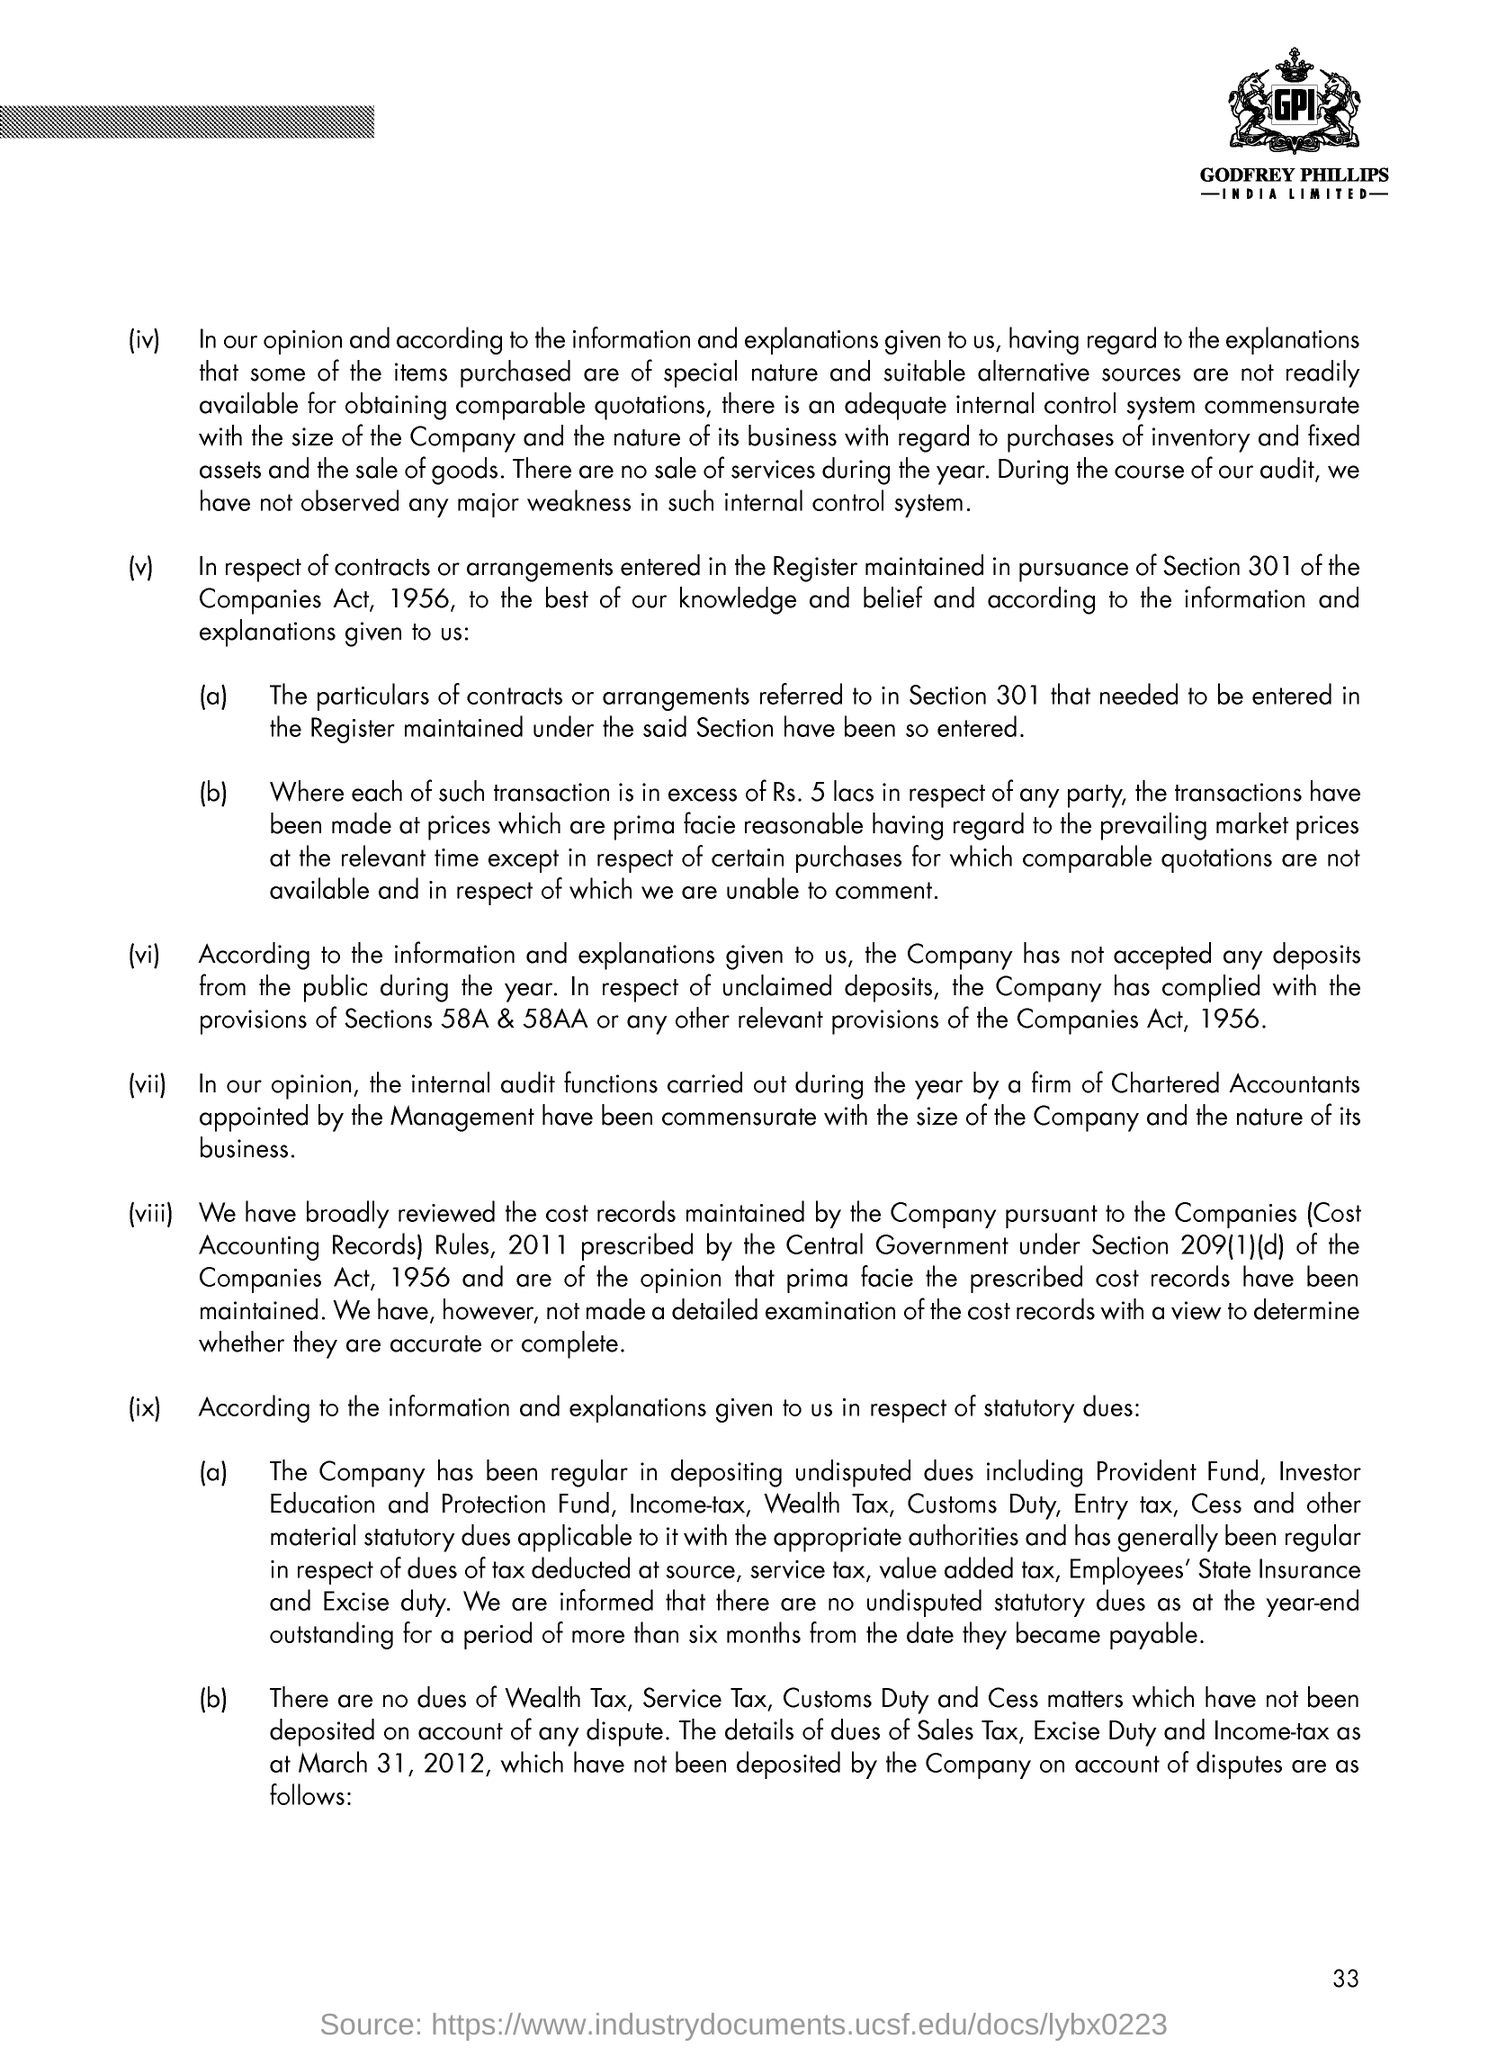Mention a couple of crucial points in this snapshot. The page number referenced in this document is 33. 